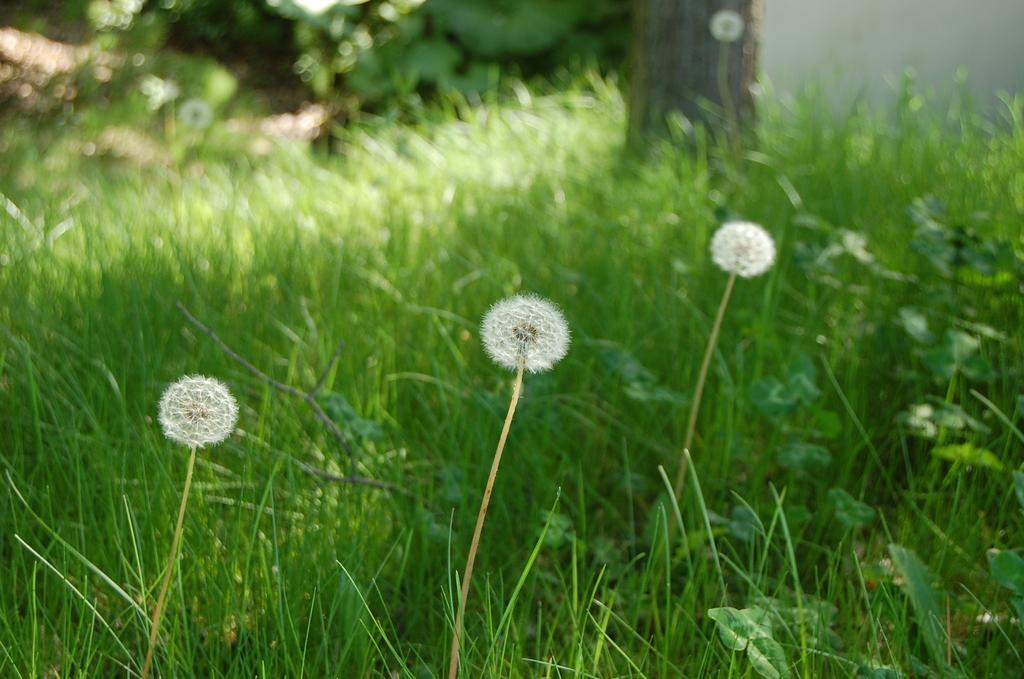What type of vegetation can be seen in the image? There is green grass in the image. Are there any specific features of the grass visible in the image? Yes, there are blooms of the grass in the image. What type of education is being provided in the image? There is no indication of education in the image; it features green grass with blooms. What kind of arch can be seen in the image? There is no arch present in the image; it only features green grass with blooms. 